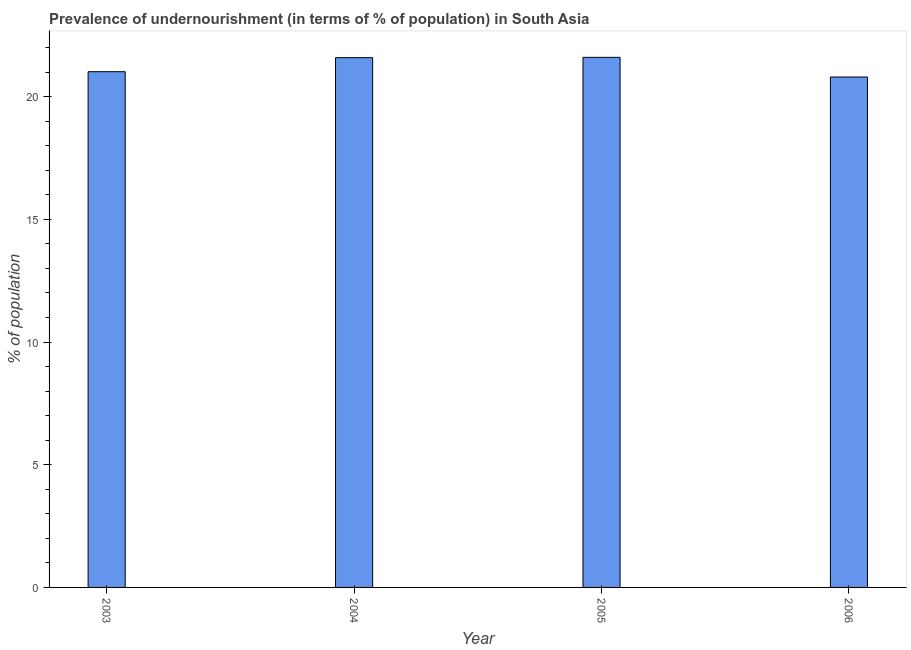What is the title of the graph?
Provide a succinct answer. Prevalence of undernourishment (in terms of % of population) in South Asia. What is the label or title of the X-axis?
Your response must be concise. Year. What is the label or title of the Y-axis?
Provide a succinct answer. % of population. What is the percentage of undernourished population in 2003?
Give a very brief answer. 21.02. Across all years, what is the maximum percentage of undernourished population?
Offer a very short reply. 21.6. Across all years, what is the minimum percentage of undernourished population?
Your response must be concise. 20.8. What is the sum of the percentage of undernourished population?
Provide a short and direct response. 85.02. What is the difference between the percentage of undernourished population in 2003 and 2004?
Provide a succinct answer. -0.57. What is the average percentage of undernourished population per year?
Make the answer very short. 21.25. What is the median percentage of undernourished population?
Your response must be concise. 21.31. Do a majority of the years between 2006 and 2004 (inclusive) have percentage of undernourished population greater than 9 %?
Provide a short and direct response. Yes. Is the percentage of undernourished population in 2003 less than that in 2006?
Ensure brevity in your answer.  No. Is the difference between the percentage of undernourished population in 2003 and 2006 greater than the difference between any two years?
Your answer should be very brief. No. What is the difference between the highest and the second highest percentage of undernourished population?
Offer a very short reply. 0.01. Is the sum of the percentage of undernourished population in 2003 and 2004 greater than the maximum percentage of undernourished population across all years?
Your answer should be very brief. Yes. What is the difference between the highest and the lowest percentage of undernourished population?
Provide a short and direct response. 0.8. How many bars are there?
Keep it short and to the point. 4. Are all the bars in the graph horizontal?
Ensure brevity in your answer.  No. How many years are there in the graph?
Your answer should be very brief. 4. Are the values on the major ticks of Y-axis written in scientific E-notation?
Provide a succinct answer. No. What is the % of population in 2003?
Offer a terse response. 21.02. What is the % of population of 2004?
Make the answer very short. 21.59. What is the % of population of 2005?
Give a very brief answer. 21.6. What is the % of population of 2006?
Give a very brief answer. 20.8. What is the difference between the % of population in 2003 and 2004?
Your response must be concise. -0.57. What is the difference between the % of population in 2003 and 2005?
Provide a short and direct response. -0.59. What is the difference between the % of population in 2003 and 2006?
Provide a short and direct response. 0.22. What is the difference between the % of population in 2004 and 2005?
Keep it short and to the point. -0.01. What is the difference between the % of population in 2004 and 2006?
Your answer should be compact. 0.79. What is the difference between the % of population in 2005 and 2006?
Your answer should be very brief. 0.8. What is the ratio of the % of population in 2003 to that in 2004?
Offer a terse response. 0.97. What is the ratio of the % of population in 2003 to that in 2006?
Offer a very short reply. 1.01. What is the ratio of the % of population in 2004 to that in 2006?
Offer a very short reply. 1.04. What is the ratio of the % of population in 2005 to that in 2006?
Keep it short and to the point. 1.04. 